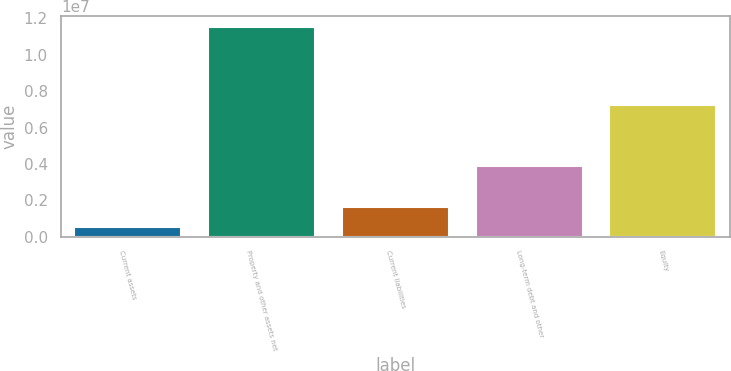<chart> <loc_0><loc_0><loc_500><loc_500><bar_chart><fcel>Current assets<fcel>Property and other assets net<fcel>Current liabilities<fcel>Long-term debt and other<fcel>Equity<nl><fcel>555615<fcel>1.15464e+07<fcel>1.65469e+06<fcel>3.90809e+06<fcel>7.24848e+06<nl></chart> 